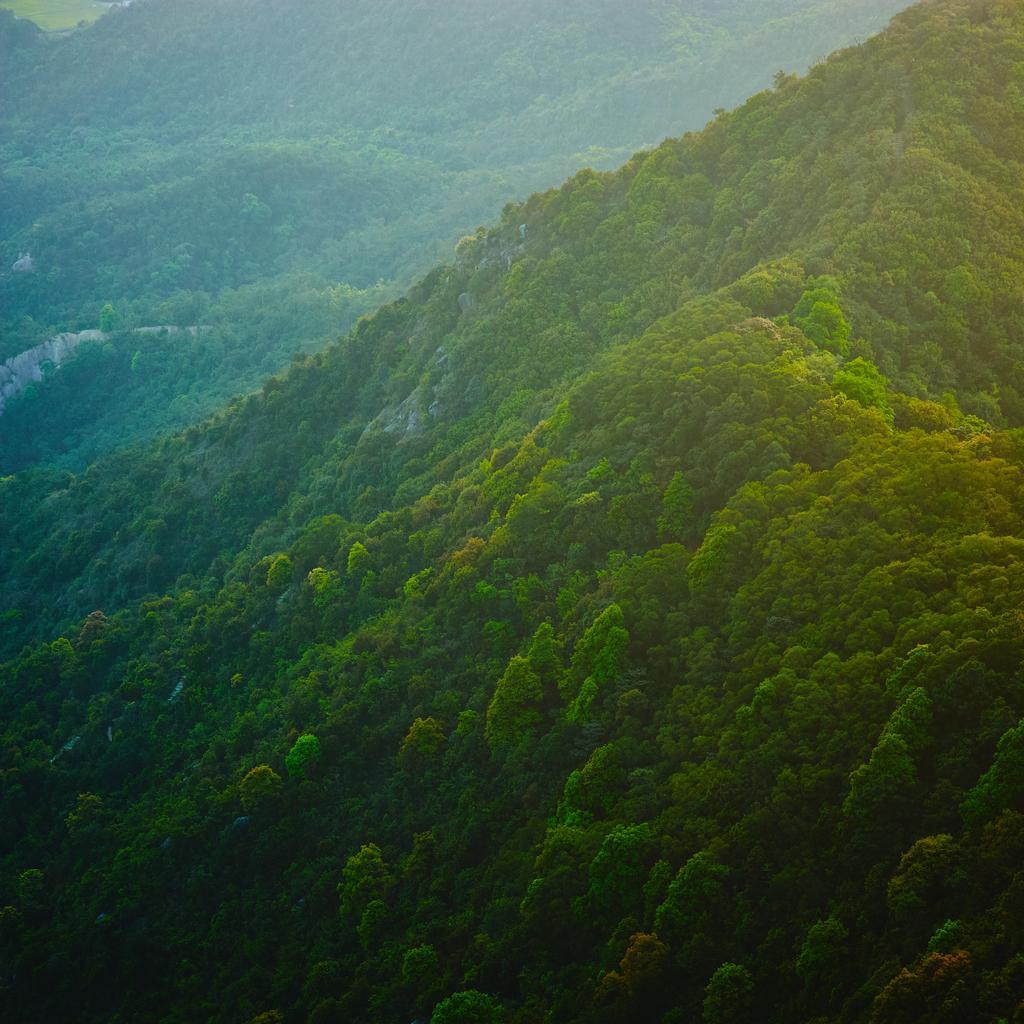In one or two sentences, can you explain what this image depicts? In this picture, there are hills covered with the trees. 